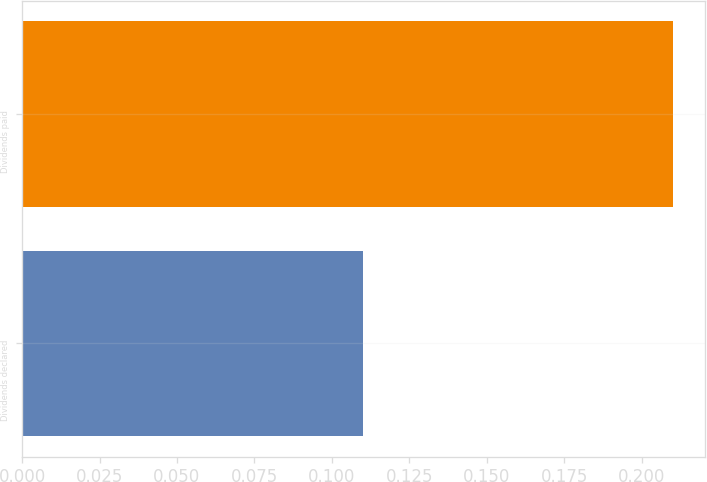Convert chart. <chart><loc_0><loc_0><loc_500><loc_500><bar_chart><fcel>Dividends declared<fcel>Dividends paid<nl><fcel>0.11<fcel>0.21<nl></chart> 